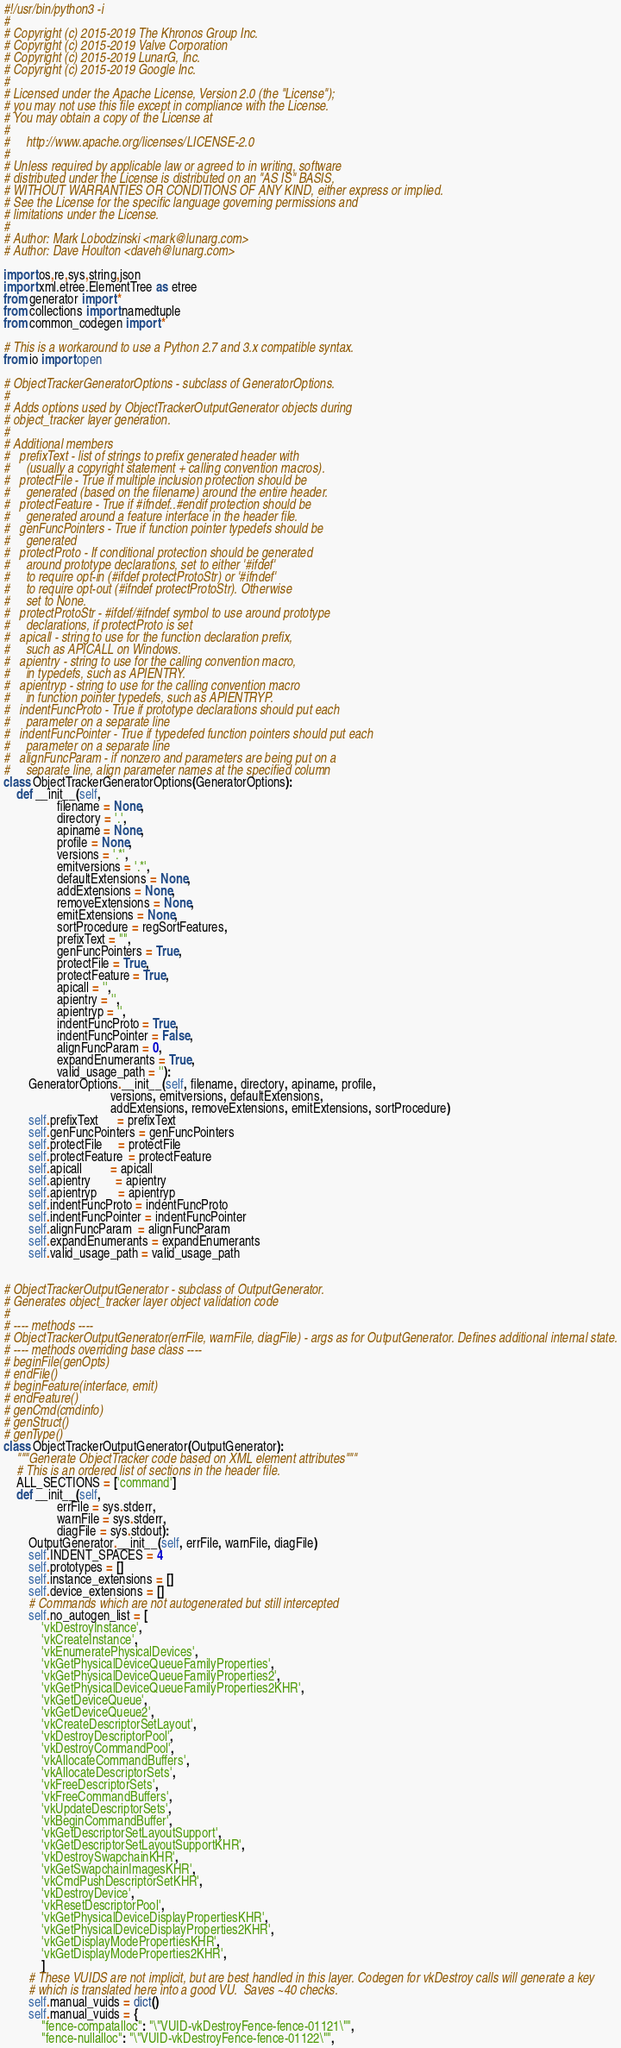Convert code to text. <code><loc_0><loc_0><loc_500><loc_500><_Python_>#!/usr/bin/python3 -i
#
# Copyright (c) 2015-2019 The Khronos Group Inc.
# Copyright (c) 2015-2019 Valve Corporation
# Copyright (c) 2015-2019 LunarG, Inc.
# Copyright (c) 2015-2019 Google Inc.
#
# Licensed under the Apache License, Version 2.0 (the "License");
# you may not use this file except in compliance with the License.
# You may obtain a copy of the License at
#
#     http://www.apache.org/licenses/LICENSE-2.0
#
# Unless required by applicable law or agreed to in writing, software
# distributed under the License is distributed on an "AS IS" BASIS,
# WITHOUT WARRANTIES OR CONDITIONS OF ANY KIND, either express or implied.
# See the License for the specific language governing permissions and
# limitations under the License.
#
# Author: Mark Lobodzinski <mark@lunarg.com>
# Author: Dave Houlton <daveh@lunarg.com>

import os,re,sys,string,json
import xml.etree.ElementTree as etree
from generator import *
from collections import namedtuple
from common_codegen import *

# This is a workaround to use a Python 2.7 and 3.x compatible syntax.
from io import open

# ObjectTrackerGeneratorOptions - subclass of GeneratorOptions.
#
# Adds options used by ObjectTrackerOutputGenerator objects during
# object_tracker layer generation.
#
# Additional members
#   prefixText - list of strings to prefix generated header with
#     (usually a copyright statement + calling convention macros).
#   protectFile - True if multiple inclusion protection should be
#     generated (based on the filename) around the entire header.
#   protectFeature - True if #ifndef..#endif protection should be
#     generated around a feature interface in the header file.
#   genFuncPointers - True if function pointer typedefs should be
#     generated
#   protectProto - If conditional protection should be generated
#     around prototype declarations, set to either '#ifdef'
#     to require opt-in (#ifdef protectProtoStr) or '#ifndef'
#     to require opt-out (#ifndef protectProtoStr). Otherwise
#     set to None.
#   protectProtoStr - #ifdef/#ifndef symbol to use around prototype
#     declarations, if protectProto is set
#   apicall - string to use for the function declaration prefix,
#     such as APICALL on Windows.
#   apientry - string to use for the calling convention macro,
#     in typedefs, such as APIENTRY.
#   apientryp - string to use for the calling convention macro
#     in function pointer typedefs, such as APIENTRYP.
#   indentFuncProto - True if prototype declarations should put each
#     parameter on a separate line
#   indentFuncPointer - True if typedefed function pointers should put each
#     parameter on a separate line
#   alignFuncParam - if nonzero and parameters are being put on a
#     separate line, align parameter names at the specified column
class ObjectTrackerGeneratorOptions(GeneratorOptions):
    def __init__(self,
                 filename = None,
                 directory = '.',
                 apiname = None,
                 profile = None,
                 versions = '.*',
                 emitversions = '.*',
                 defaultExtensions = None,
                 addExtensions = None,
                 removeExtensions = None,
                 emitExtensions = None,
                 sortProcedure = regSortFeatures,
                 prefixText = "",
                 genFuncPointers = True,
                 protectFile = True,
                 protectFeature = True,
                 apicall = '',
                 apientry = '',
                 apientryp = '',
                 indentFuncProto = True,
                 indentFuncPointer = False,
                 alignFuncParam = 0,
                 expandEnumerants = True,
                 valid_usage_path = ''):
        GeneratorOptions.__init__(self, filename, directory, apiname, profile,
                                  versions, emitversions, defaultExtensions,
                                  addExtensions, removeExtensions, emitExtensions, sortProcedure)
        self.prefixText      = prefixText
        self.genFuncPointers = genFuncPointers
        self.protectFile     = protectFile
        self.protectFeature  = protectFeature
        self.apicall         = apicall
        self.apientry        = apientry
        self.apientryp       = apientryp
        self.indentFuncProto = indentFuncProto
        self.indentFuncPointer = indentFuncPointer
        self.alignFuncParam  = alignFuncParam
        self.expandEnumerants = expandEnumerants
        self.valid_usage_path = valid_usage_path


# ObjectTrackerOutputGenerator - subclass of OutputGenerator.
# Generates object_tracker layer object validation code
#
# ---- methods ----
# ObjectTrackerOutputGenerator(errFile, warnFile, diagFile) - args as for OutputGenerator. Defines additional internal state.
# ---- methods overriding base class ----
# beginFile(genOpts)
# endFile()
# beginFeature(interface, emit)
# endFeature()
# genCmd(cmdinfo)
# genStruct()
# genType()
class ObjectTrackerOutputGenerator(OutputGenerator):
    """Generate ObjectTracker code based on XML element attributes"""
    # This is an ordered list of sections in the header file.
    ALL_SECTIONS = ['command']
    def __init__(self,
                 errFile = sys.stderr,
                 warnFile = sys.stderr,
                 diagFile = sys.stdout):
        OutputGenerator.__init__(self, errFile, warnFile, diagFile)
        self.INDENT_SPACES = 4
        self.prototypes = []
        self.instance_extensions = []
        self.device_extensions = []
        # Commands which are not autogenerated but still intercepted
        self.no_autogen_list = [
            'vkDestroyInstance',
            'vkCreateInstance',
            'vkEnumeratePhysicalDevices',
            'vkGetPhysicalDeviceQueueFamilyProperties',
            'vkGetPhysicalDeviceQueueFamilyProperties2',
            'vkGetPhysicalDeviceQueueFamilyProperties2KHR',
            'vkGetDeviceQueue',
            'vkGetDeviceQueue2',
            'vkCreateDescriptorSetLayout',
            'vkDestroyDescriptorPool',
            'vkDestroyCommandPool',
            'vkAllocateCommandBuffers',
            'vkAllocateDescriptorSets',
            'vkFreeDescriptorSets',
            'vkFreeCommandBuffers',
            'vkUpdateDescriptorSets',
            'vkBeginCommandBuffer',
            'vkGetDescriptorSetLayoutSupport',
            'vkGetDescriptorSetLayoutSupportKHR',
            'vkDestroySwapchainKHR',
            'vkGetSwapchainImagesKHR',
            'vkCmdPushDescriptorSetKHR',
            'vkDestroyDevice',
            'vkResetDescriptorPool',
            'vkGetPhysicalDeviceDisplayPropertiesKHR',
            'vkGetPhysicalDeviceDisplayProperties2KHR',
            'vkGetDisplayModePropertiesKHR',
            'vkGetDisplayModeProperties2KHR',
            ]
        # These VUIDS are not implicit, but are best handled in this layer. Codegen for vkDestroy calls will generate a key
        # which is translated here into a good VU.  Saves ~40 checks.
        self.manual_vuids = dict()
        self.manual_vuids = {
            "fence-compatalloc": "\"VUID-vkDestroyFence-fence-01121\"",
            "fence-nullalloc": "\"VUID-vkDestroyFence-fence-01122\"",</code> 